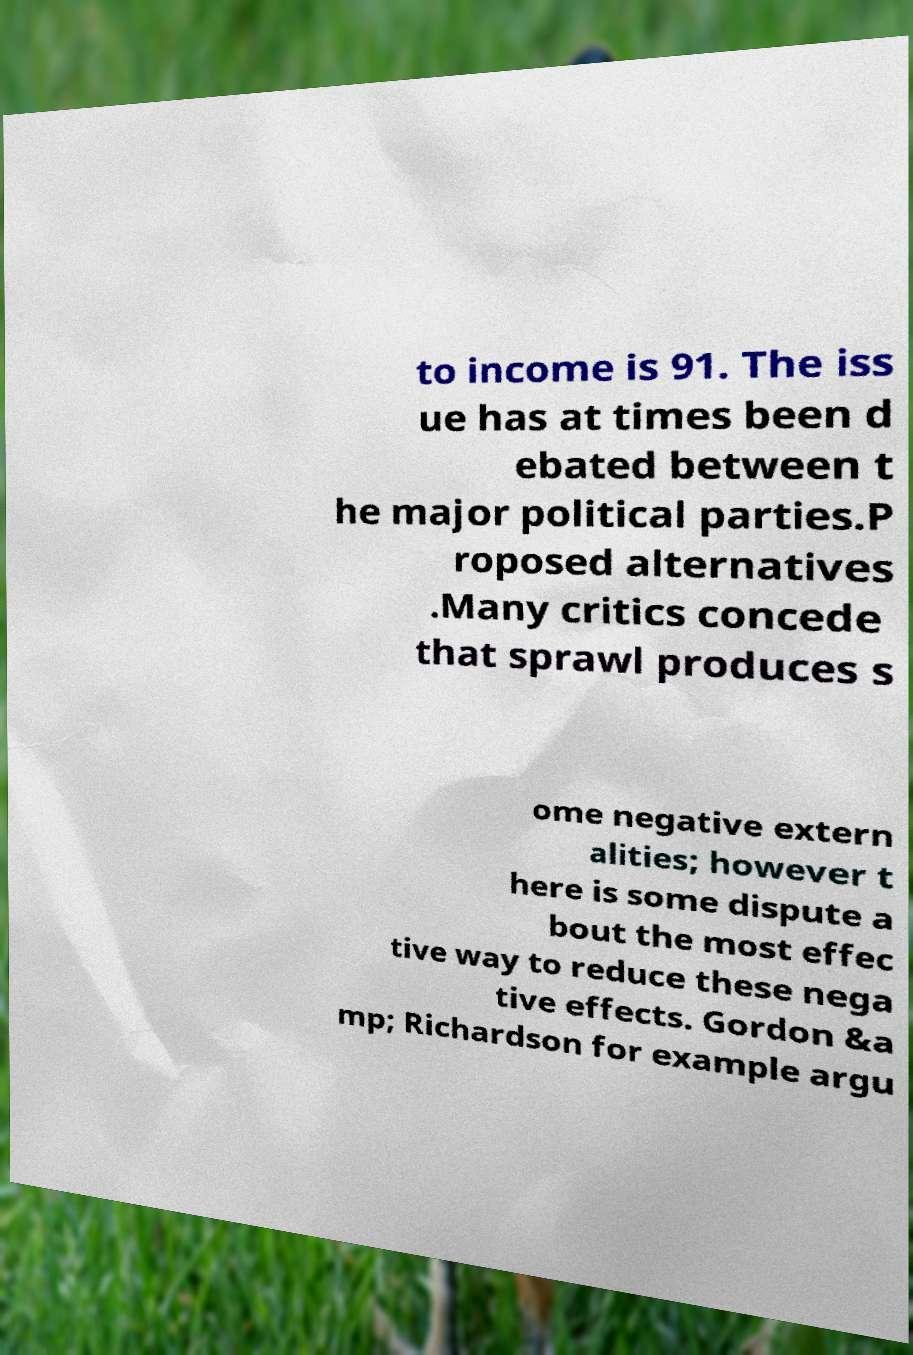Can you accurately transcribe the text from the provided image for me? to income is 91. The iss ue has at times been d ebated between t he major political parties.P roposed alternatives .Many critics concede that sprawl produces s ome negative extern alities; however t here is some dispute a bout the most effec tive way to reduce these nega tive effects. Gordon &a mp; Richardson for example argu 